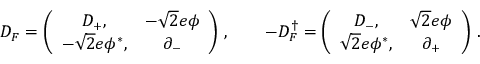Convert formula to latex. <formula><loc_0><loc_0><loc_500><loc_500>D _ { F } = \left ( \begin{array} { c c } { { D _ { + } , } } & { { - \sqrt { 2 } e \phi } } \\ { { - \sqrt { 2 } e \phi ^ { * } , } } & { { \partial _ { - } } } \end{array} \right ) \, , \quad - D _ { F } ^ { \dag } = \left ( \begin{array} { c c } { { D _ { - } , } } & { { \sqrt { 2 } e \phi } } \\ { { \sqrt { 2 } e \phi ^ { * } , } } & { { \partial _ { + } } } \end{array} \right ) \, .</formula> 